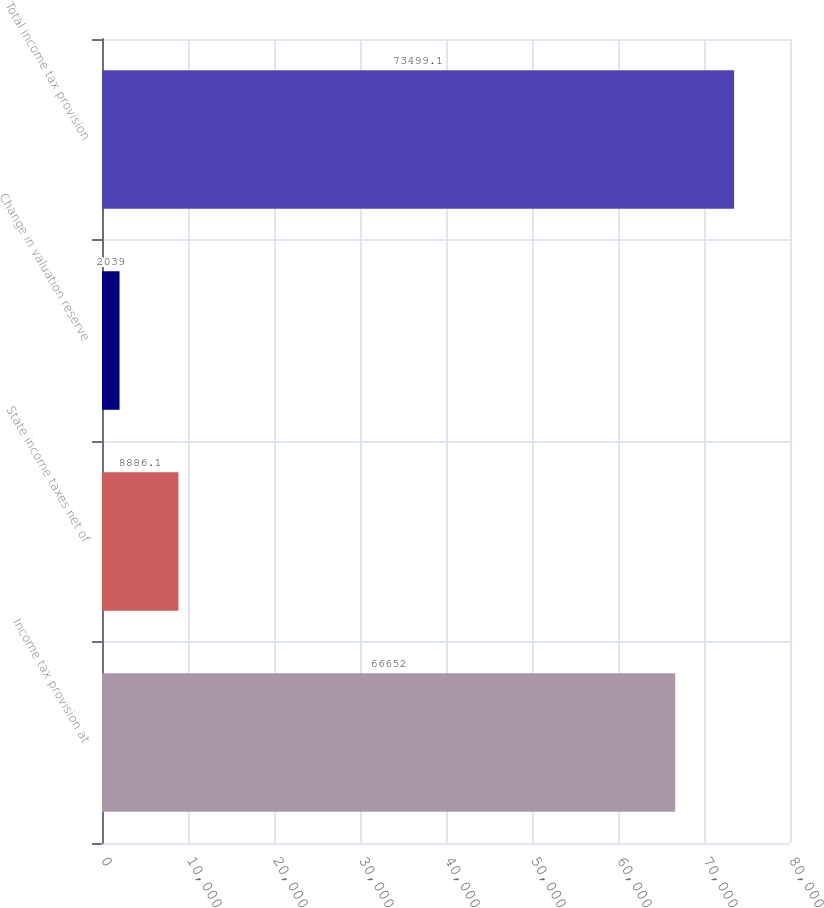Convert chart. <chart><loc_0><loc_0><loc_500><loc_500><bar_chart><fcel>Income tax provision at<fcel>State income taxes net of<fcel>Change in valuation reserve<fcel>Total income tax provision<nl><fcel>66652<fcel>8886.1<fcel>2039<fcel>73499.1<nl></chart> 